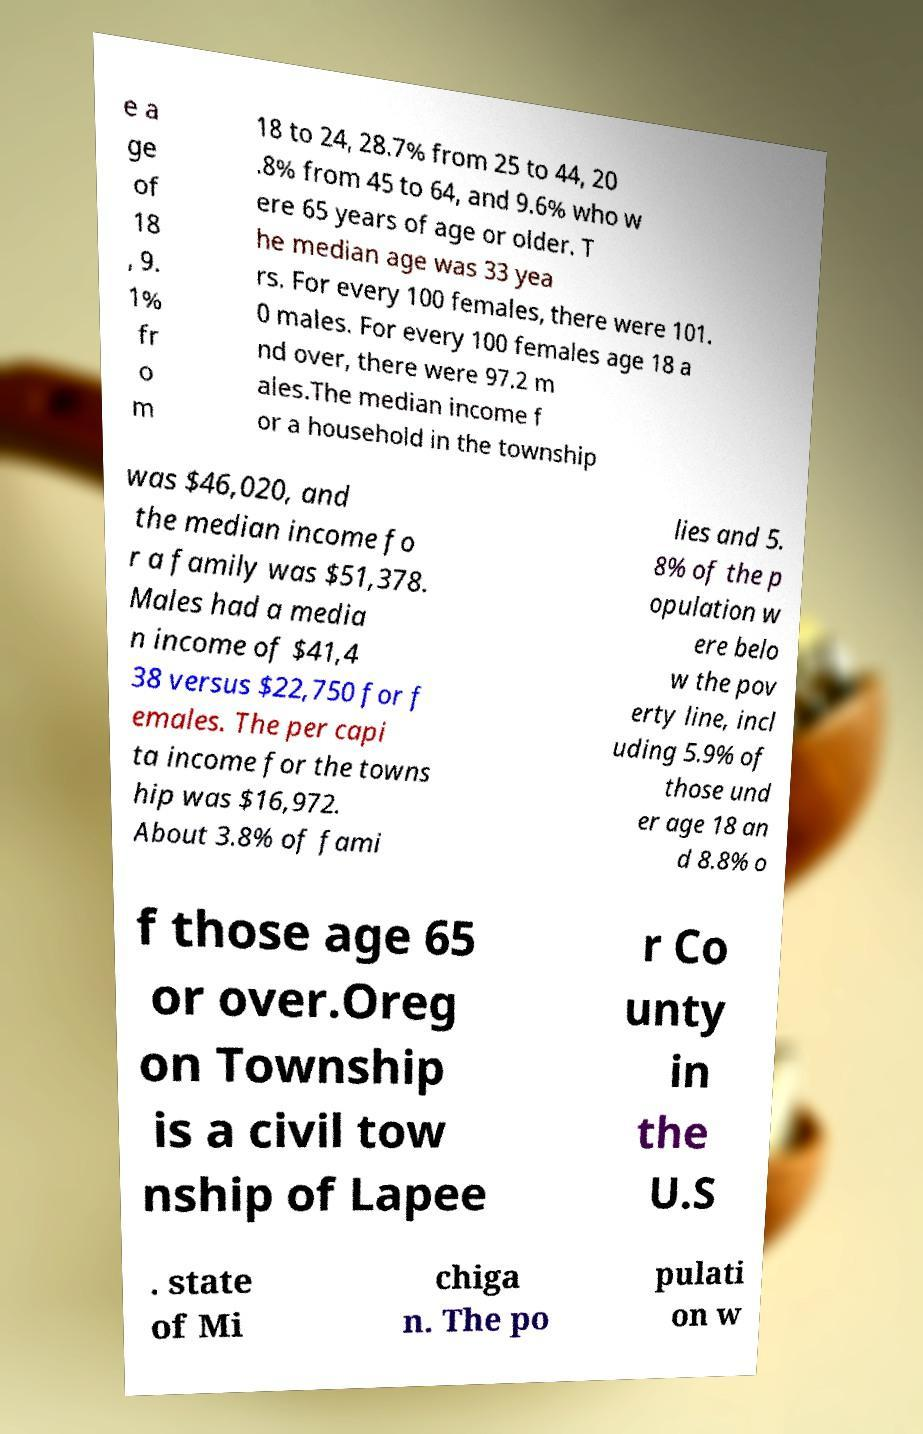I need the written content from this picture converted into text. Can you do that? e a ge of 18 , 9. 1% fr o m 18 to 24, 28.7% from 25 to 44, 20 .8% from 45 to 64, and 9.6% who w ere 65 years of age or older. T he median age was 33 yea rs. For every 100 females, there were 101. 0 males. For every 100 females age 18 a nd over, there were 97.2 m ales.The median income f or a household in the township was $46,020, and the median income fo r a family was $51,378. Males had a media n income of $41,4 38 versus $22,750 for f emales. The per capi ta income for the towns hip was $16,972. About 3.8% of fami lies and 5. 8% of the p opulation w ere belo w the pov erty line, incl uding 5.9% of those und er age 18 an d 8.8% o f those age 65 or over.Oreg on Township is a civil tow nship of Lapee r Co unty in the U.S . state of Mi chiga n. The po pulati on w 